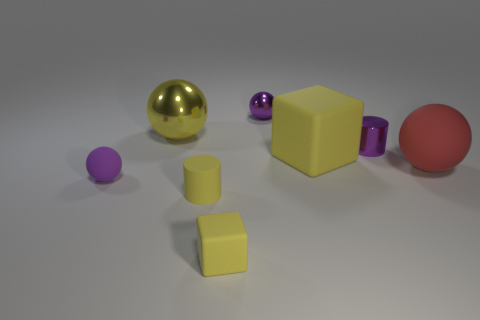There is a large red thing that is the same shape as the small purple matte thing; what is its material?
Ensure brevity in your answer.  Rubber. What number of spheres are either big yellow things or purple matte things?
Offer a very short reply. 2. What number of objects are either blocks that are right of the tiny rubber cube or big green spheres?
Your response must be concise. 1. The yellow matte object that is to the right of the tiny yellow cube that is right of the tiny cylinder in front of the tiny purple cylinder is what shape?
Provide a succinct answer. Cube. How many big green rubber things are the same shape as the small purple matte thing?
Offer a terse response. 0. There is a cylinder that is the same color as the big rubber block; what material is it?
Provide a succinct answer. Rubber. Is the material of the small cube the same as the big cube?
Provide a succinct answer. Yes. What number of big shiny spheres are left of the tiny cylinder that is left of the cylinder that is to the right of the big yellow block?
Keep it short and to the point. 1. Is there a tiny brown cylinder that has the same material as the large red object?
Make the answer very short. No. There is a matte object that is the same color as the small metallic cylinder; what is its size?
Provide a short and direct response. Small. 